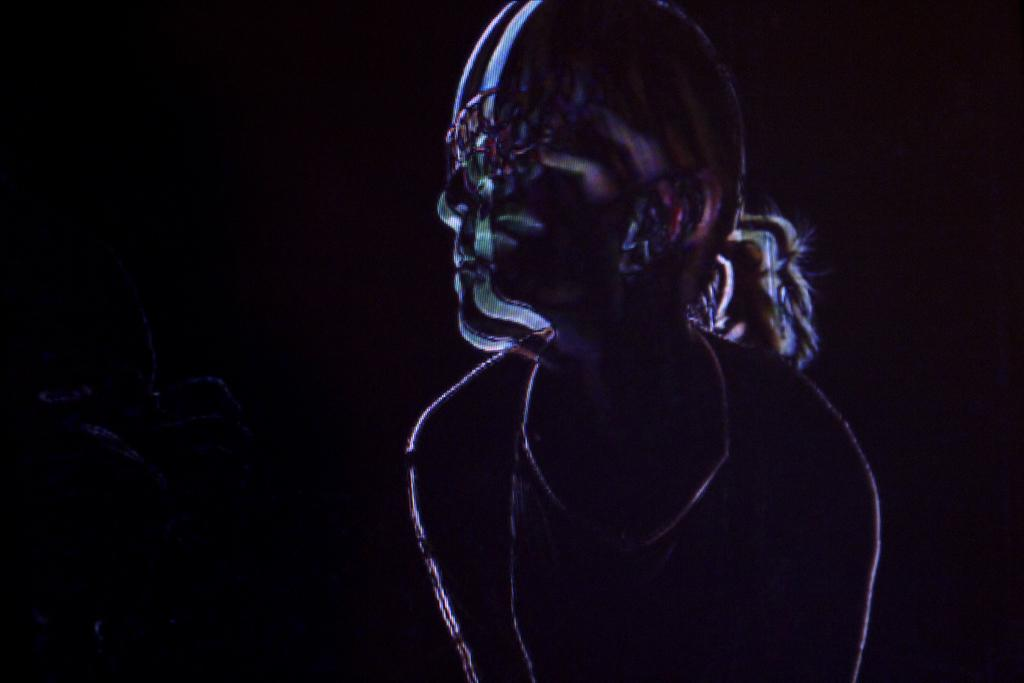Who is the main subject in the foreground of the image? There is a woman in the foreground of the image. What can be observed about the background of the image? The background of the image is dark. What type of soup is being served in the image? There is no soup present in the image; it features a woman in the foreground and a dark background. How many things are present in the image? The number of things in the image cannot be determined from the provided facts, as the term "things" is too vague. 